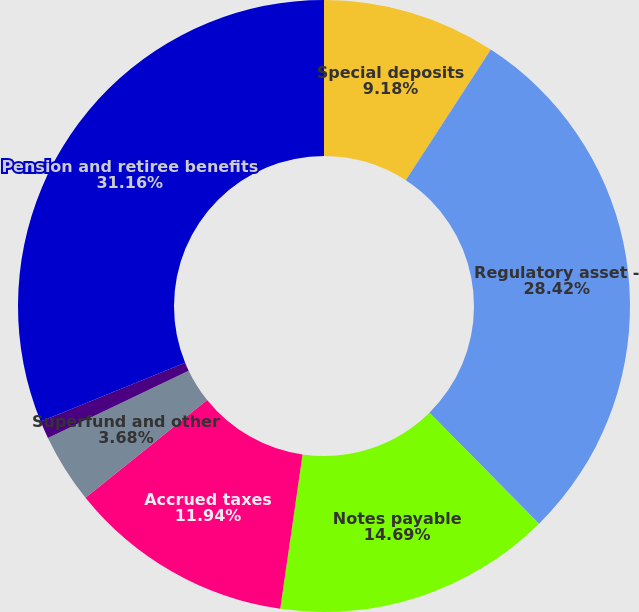Convert chart. <chart><loc_0><loc_0><loc_500><loc_500><pie_chart><fcel>Special deposits<fcel>Regulatory asset -<fcel>Notes payable<fcel>Accrued taxes<fcel>Superfund and other<fcel>Accrued interest<fcel>Pension and retiree benefits<nl><fcel>9.18%<fcel>28.42%<fcel>14.69%<fcel>11.94%<fcel>3.68%<fcel>0.93%<fcel>31.17%<nl></chart> 